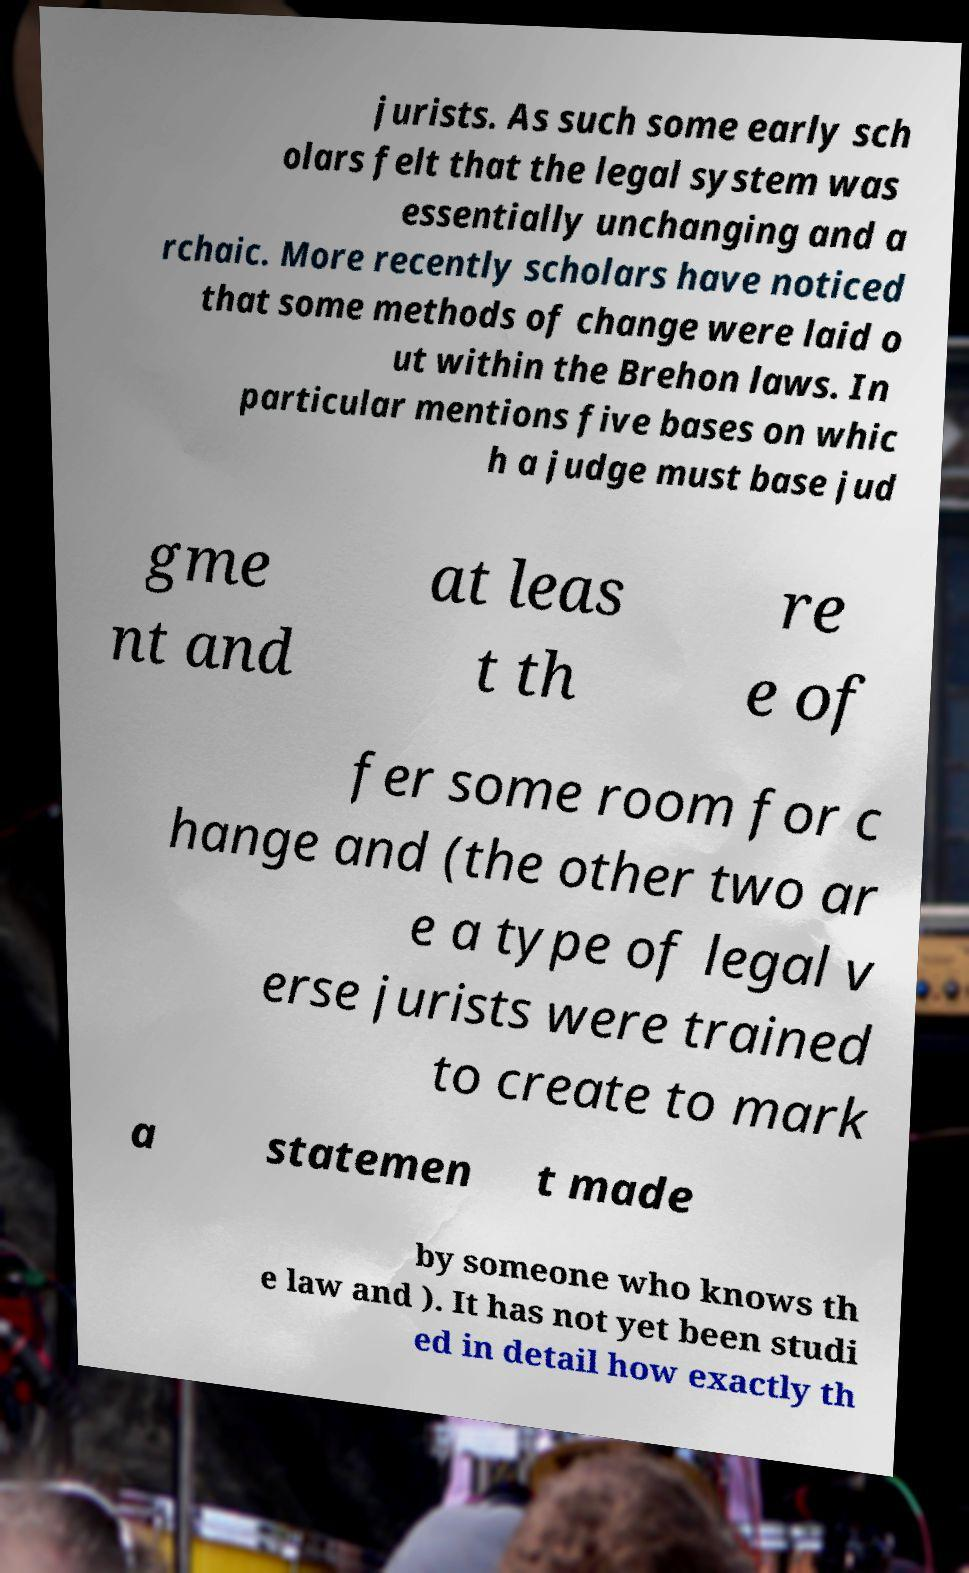I need the written content from this picture converted into text. Can you do that? jurists. As such some early sch olars felt that the legal system was essentially unchanging and a rchaic. More recently scholars have noticed that some methods of change were laid o ut within the Brehon laws. In particular mentions five bases on whic h a judge must base jud gme nt and at leas t th re e of fer some room for c hange and (the other two ar e a type of legal v erse jurists were trained to create to mark a statemen t made by someone who knows th e law and ). It has not yet been studi ed in detail how exactly th 